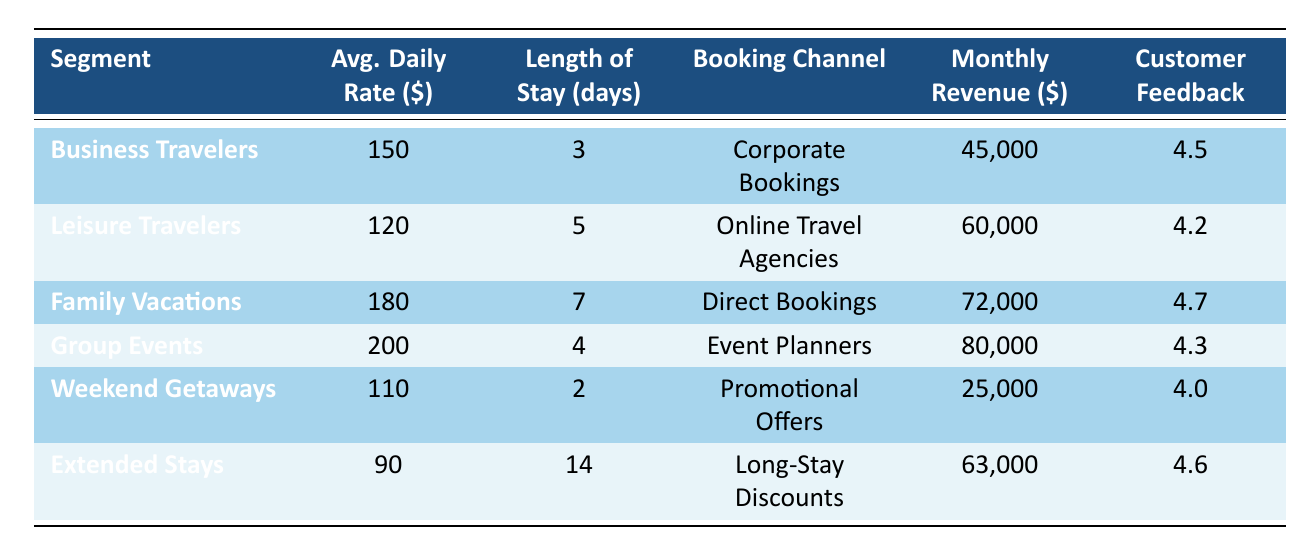What is the average daily rate for Family Vacations? The table shows that the average daily rate for the Family Vacations segment is listed directly as 180.
Answer: 180 Which customer segment has the highest monthly revenue? By examining the 'Monthly Revenue' column, the Group Events segment has the highest value at 80,000, making it the segment with the highest monthly revenue.
Answer: Group Events Is the average daily rate for Weekend Getaways lower than that of Business Travelers? The average daily rate for Weekend Getaways is 110, while for Business Travelers it is 150. Since 110 is less than 150, the statement is true.
Answer: Yes What is the total monthly revenue from Business Travelers and Weekend Getaways? To find the total monthly revenue, we sum the monthly revenue of Business Travelers (45,000) and Weekend Getaways (25,000): 45,000 + 25,000 = 70,000.
Answer: 70,000 Which customer segment has the longest average length of stay? Among all the segments, Extended Stays has the longest average length of stay at 14 days, as seen in the 'Length of Stay' column.
Answer: Extended Stays Are customers giving higher feedback scores to Family Vacations compared to Leisure Travelers? The feedback score for Family Vacations is 4.7, which is greater than Leisure Travelers' feedback score of 4.2, confirming that customers are giving higher scores to Family Vacations.
Answer: Yes What is the average customer feedback score of all segments? To find the average, we add the feedback scores (4.5 + 4.2 + 4.7 + 4.3 + 4.0 + 4.6 = 26.3) and divide by the number of segments (6): 26.3 / 6 = 4.383.
Answer: 4.383 Which booking channel is associated with the highest monthly revenue? The booking channel for Group Events, which is associated with the highest monthly revenue of 80,000, indicates that Event Planners is the channel with the highest revenue contribution.
Answer: Event Planners How many segments have an average daily rate of 100 or more? By checking the average daily rates, we find Business Travelers, Leisure Travelers, Family Vacations, Group Events, and Weekend Getaways all exceed 100, making a total of 5 segments.
Answer: 5 